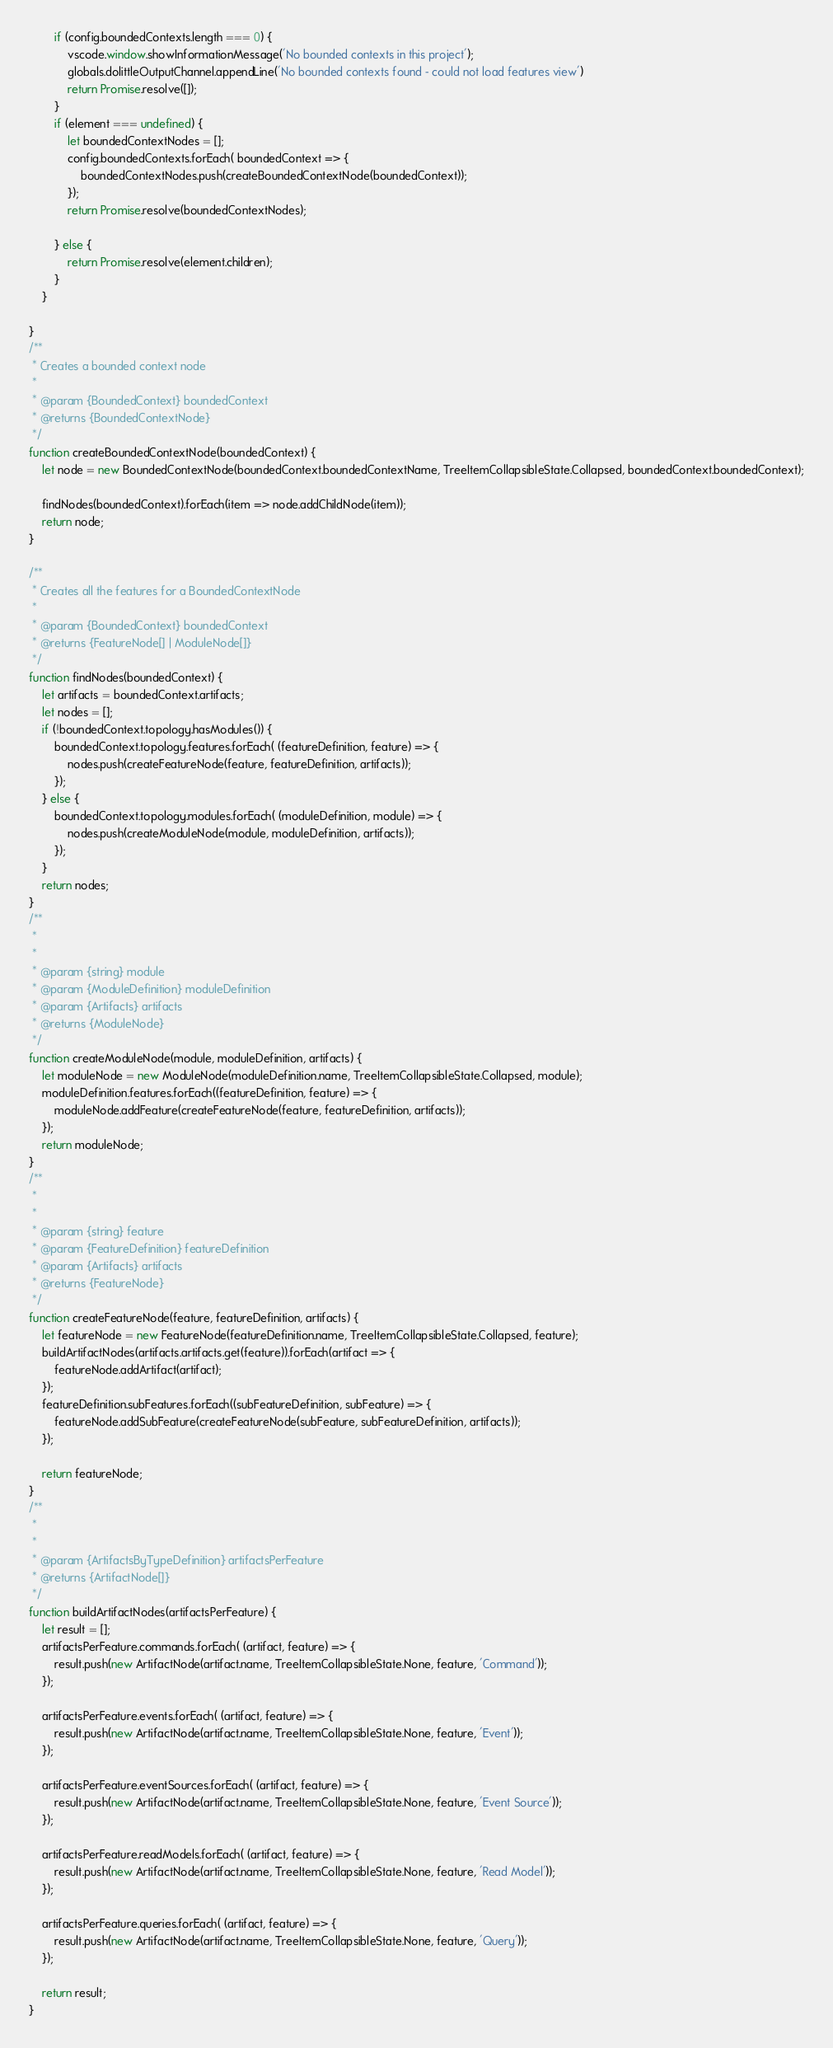Convert code to text. <code><loc_0><loc_0><loc_500><loc_500><_JavaScript_>        if (config.boundedContexts.length === 0) {
            vscode.window.showInformationMessage('No bounded contexts in this project');
            globals.dolittleOutputChannel.appendLine('No bounded contexts found - could not load features view')
            return Promise.resolve([]);
        }
        if (element === undefined) {
            let boundedContextNodes = [];
            config.boundedContexts.forEach( boundedContext => {
                boundedContextNodes.push(createBoundedContextNode(boundedContext));
            });
            return Promise.resolve(boundedContextNodes);

        } else {
            return Promise.resolve(element.children);
        }
    }
    
}
/**
 * Creates a bounded context node
 *
 * @param {BoundedContext} boundedContext
 * @returns {BoundedContextNode}
 */
function createBoundedContextNode(boundedContext) {
    let node = new BoundedContextNode(boundedContext.boundedContextName, TreeItemCollapsibleState.Collapsed, boundedContext.boundedContext);
    
    findNodes(boundedContext).forEach(item => node.addChildNode(item));
    return node;
}

/**
 * Creates all the features for a BoundedContextNode
 *
 * @param {BoundedContext} boundedContext
 * @returns {FeatureNode[] | ModuleNode[]}
 */
function findNodes(boundedContext) {
    let artifacts = boundedContext.artifacts;
    let nodes = [];
    if (!boundedContext.topology.hasModules()) {
        boundedContext.topology.features.forEach( (featureDefinition, feature) => {
            nodes.push(createFeatureNode(feature, featureDefinition, artifacts));
        });
    } else {
        boundedContext.topology.modules.forEach( (moduleDefinition, module) => {
            nodes.push(createModuleNode(module, moduleDefinition, artifacts));
        });
    }
    return nodes;
}
/**
 *
 *
 * @param {string} module
 * @param {ModuleDefinition} moduleDefinition
 * @param {Artifacts} artifacts
 * @returns {ModuleNode}
 */
function createModuleNode(module, moduleDefinition, artifacts) {
    let moduleNode = new ModuleNode(moduleDefinition.name, TreeItemCollapsibleState.Collapsed, module);
    moduleDefinition.features.forEach((featureDefinition, feature) => {
        moduleNode.addFeature(createFeatureNode(feature, featureDefinition, artifacts));
    });
    return moduleNode;
}
/**
 *
 *
 * @param {string} feature
 * @param {FeatureDefinition} featureDefinition
 * @param {Artifacts} artifacts
 * @returns {FeatureNode}
 */
function createFeatureNode(feature, featureDefinition, artifacts) {
    let featureNode = new FeatureNode(featureDefinition.name, TreeItemCollapsibleState.Collapsed, feature);
    buildArtifactNodes(artifacts.artifacts.get(feature)).forEach(artifact => {
        featureNode.addArtifact(artifact);
    });
    featureDefinition.subFeatures.forEach((subFeatureDefinition, subFeature) => {
        featureNode.addSubFeature(createFeatureNode(subFeature, subFeatureDefinition, artifacts));
    });

    return featureNode;
}
/**
 *
 *
 * @param {ArtifactsByTypeDefinition} artifactsPerFeature
 * @returns {ArtifactNode[]}
 */
function buildArtifactNodes(artifactsPerFeature) {
    let result = [];
    artifactsPerFeature.commands.forEach( (artifact, feature) => {
        result.push(new ArtifactNode(artifact.name, TreeItemCollapsibleState.None, feature, 'Command'));
    });

    artifactsPerFeature.events.forEach( (artifact, feature) => {
        result.push(new ArtifactNode(artifact.name, TreeItemCollapsibleState.None, feature, 'Event'));
    });

    artifactsPerFeature.eventSources.forEach( (artifact, feature) => {
        result.push(new ArtifactNode(artifact.name, TreeItemCollapsibleState.None, feature, 'Event Source'));
    });

    artifactsPerFeature.readModels.forEach( (artifact, feature) => {
        result.push(new ArtifactNode(artifact.name, TreeItemCollapsibleState.None, feature, 'Read Model'));
    });

    artifactsPerFeature.queries.forEach( (artifact, feature) => {
        result.push(new ArtifactNode(artifact.name, TreeItemCollapsibleState.None, feature, 'Query'));
    });

    return result;
}
</code> 